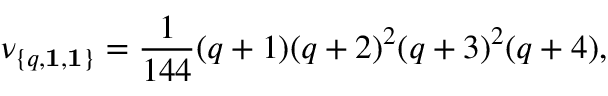<formula> <loc_0><loc_0><loc_500><loc_500>\nu _ { \{ q , { 1 } , { 1 } \} } = { \frac { 1 } { 1 4 4 } } ( q + 1 ) ( q + 2 ) ^ { 2 } ( q + 3 ) ^ { 2 } ( q + 4 ) ,</formula> 